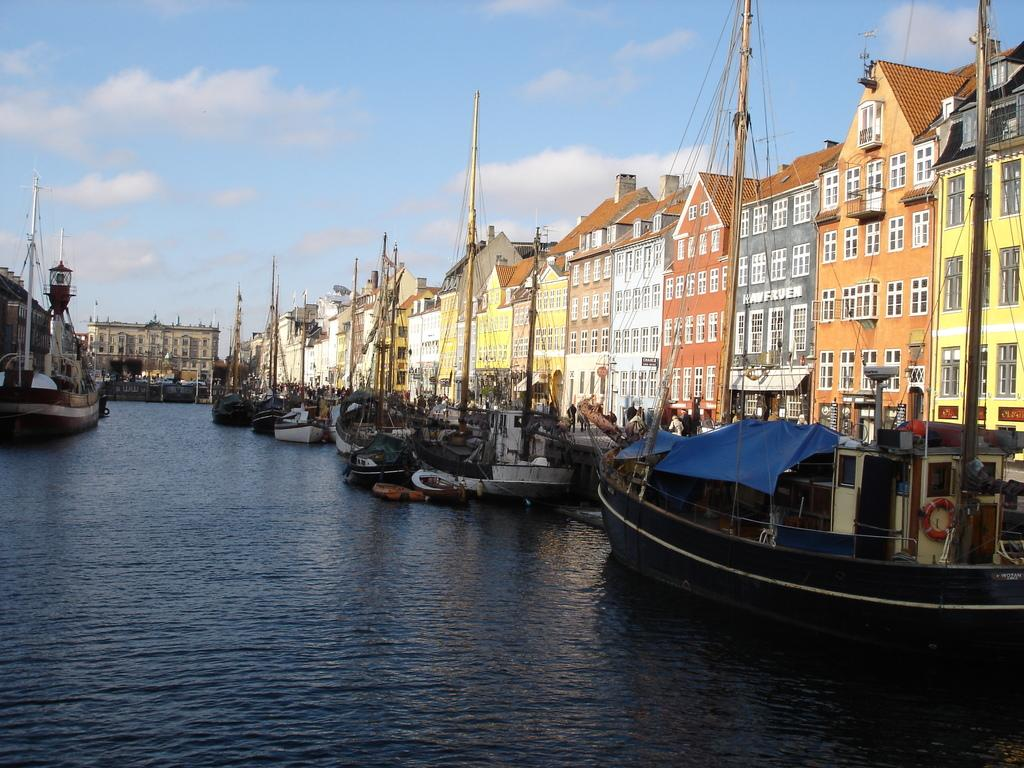What type of structures can be seen in the image? There are buildings in the image. What else is present in the image besides buildings? There are boats and other objects in the image. What can be seen in the background of the image? The sky is visible in the background of the image. What is at the bottom of the image? There is water at the bottom of the image. What type of pollution is visible in the image? There is no visible pollution in the image. What type of destruction can be seen in the image? There is no destruction visible in the image. 